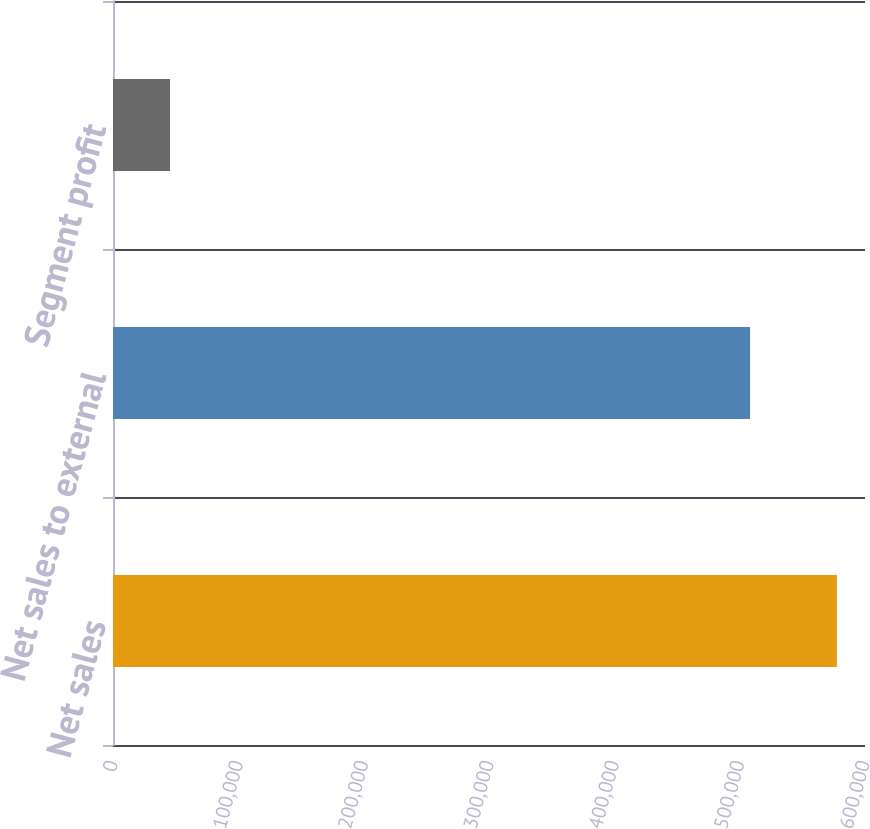Convert chart. <chart><loc_0><loc_0><loc_500><loc_500><bar_chart><fcel>Net sales<fcel>Net sales to external<fcel>Segment profit<nl><fcel>577582<fcel>508289<fcel>45466<nl></chart> 